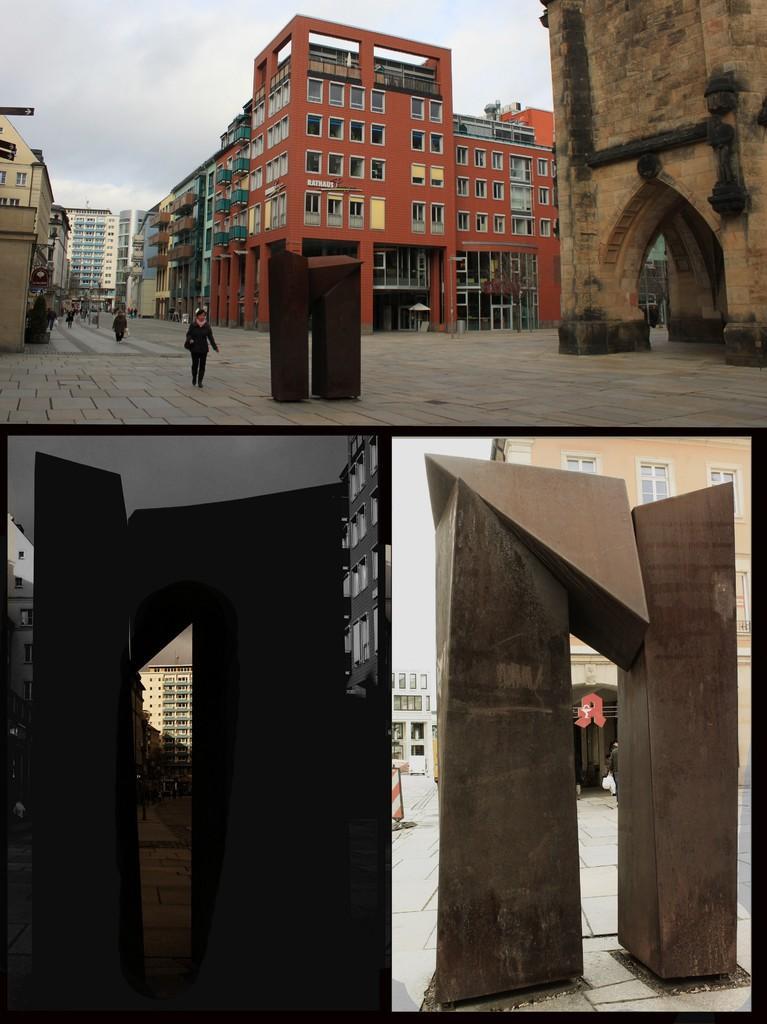Describe this image in one or two sentences. This is a collage. On the first image, there are buildings with windows and doors. Also there are some people on the road. In the center there are two pillars. On the right side there is another building with arches. In the background there is sky. Below that there are two images. On the left side it is dark and right side it is having light. Both images have pillars and there is building in the background. 